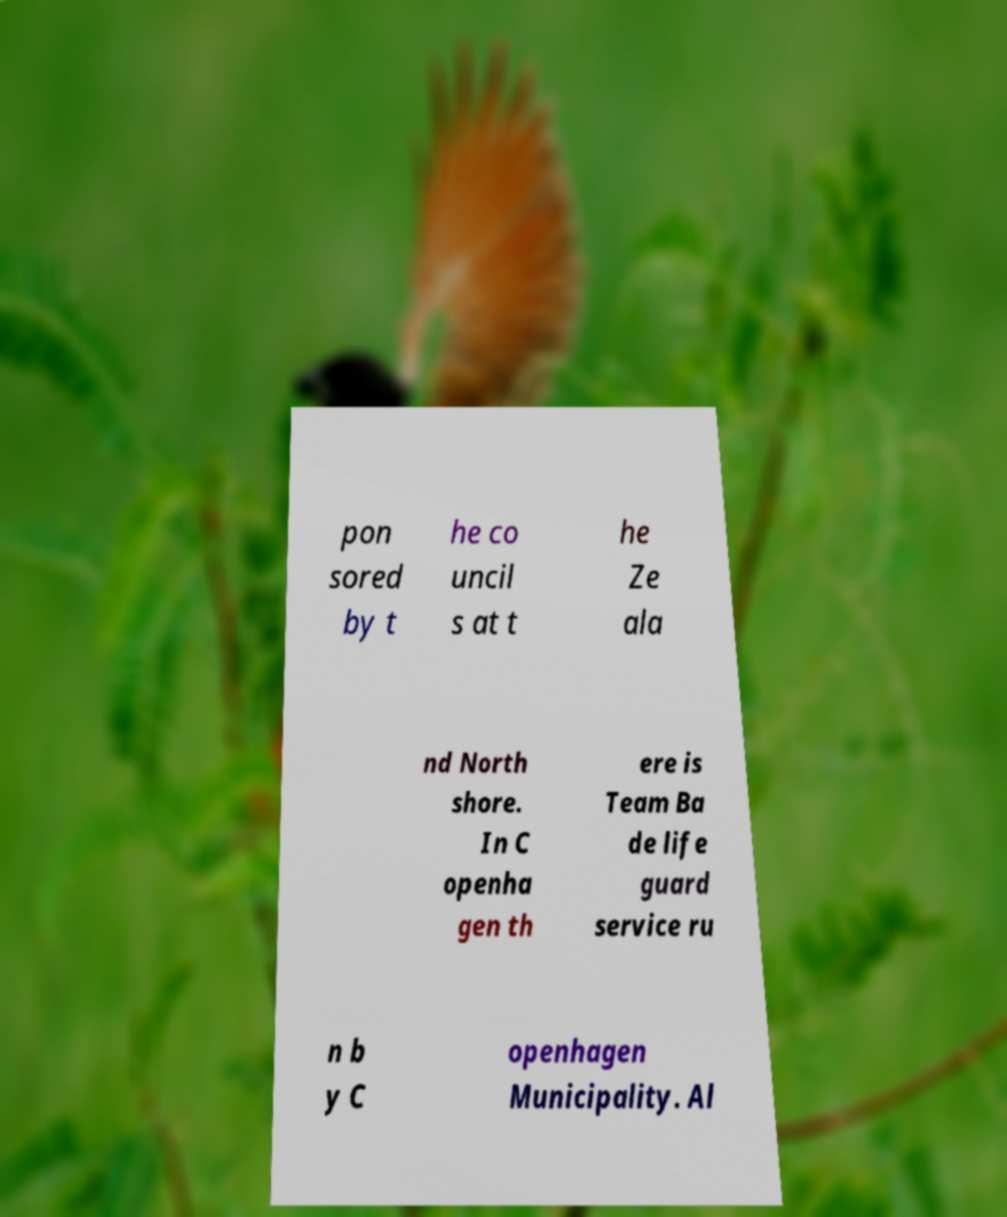What messages or text are displayed in this image? I need them in a readable, typed format. pon sored by t he co uncil s at t he Ze ala nd North shore. In C openha gen th ere is Team Ba de life guard service ru n b y C openhagen Municipality. Al 